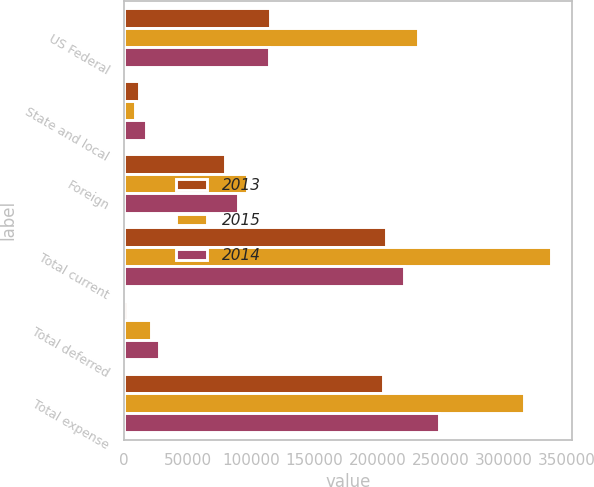Convert chart to OTSL. <chart><loc_0><loc_0><loc_500><loc_500><stacked_bar_chart><ecel><fcel>US Federal<fcel>State and local<fcel>Foreign<fcel>Total current<fcel>Total deferred<fcel>Total expense<nl><fcel>2013<fcel>115130<fcel>11706<fcel>79982<fcel>206818<fcel>2089<fcel>204729<nl><fcel>2015<fcel>231939<fcel>8434<fcel>97037<fcel>337410<fcel>21343<fcel>316067<nl><fcel>2014<fcel>114218<fcel>17468<fcel>89702<fcel>221388<fcel>27071<fcel>248459<nl></chart> 